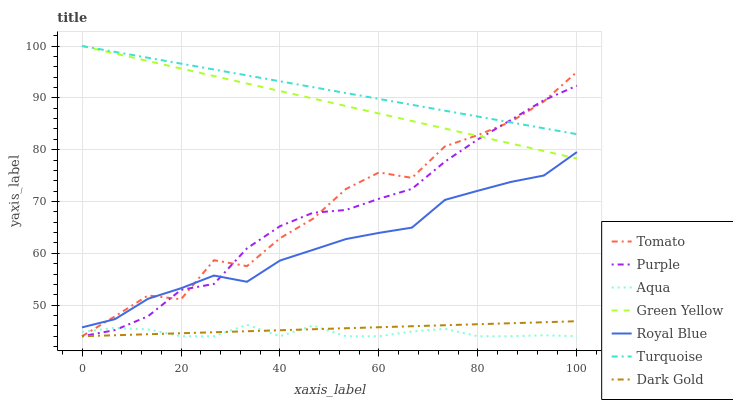Does Aqua have the minimum area under the curve?
Answer yes or no. Yes. Does Turquoise have the maximum area under the curve?
Answer yes or no. Yes. Does Dark Gold have the minimum area under the curve?
Answer yes or no. No. Does Dark Gold have the maximum area under the curve?
Answer yes or no. No. Is Dark Gold the smoothest?
Answer yes or no. Yes. Is Tomato the roughest?
Answer yes or no. Yes. Is Turquoise the smoothest?
Answer yes or no. No. Is Turquoise the roughest?
Answer yes or no. No. Does Tomato have the lowest value?
Answer yes or no. Yes. Does Turquoise have the lowest value?
Answer yes or no. No. Does Green Yellow have the highest value?
Answer yes or no. Yes. Does Dark Gold have the highest value?
Answer yes or no. No. Is Aqua less than Green Yellow?
Answer yes or no. Yes. Is Green Yellow greater than Aqua?
Answer yes or no. Yes. Does Dark Gold intersect Purple?
Answer yes or no. Yes. Is Dark Gold less than Purple?
Answer yes or no. No. Is Dark Gold greater than Purple?
Answer yes or no. No. Does Aqua intersect Green Yellow?
Answer yes or no. No. 